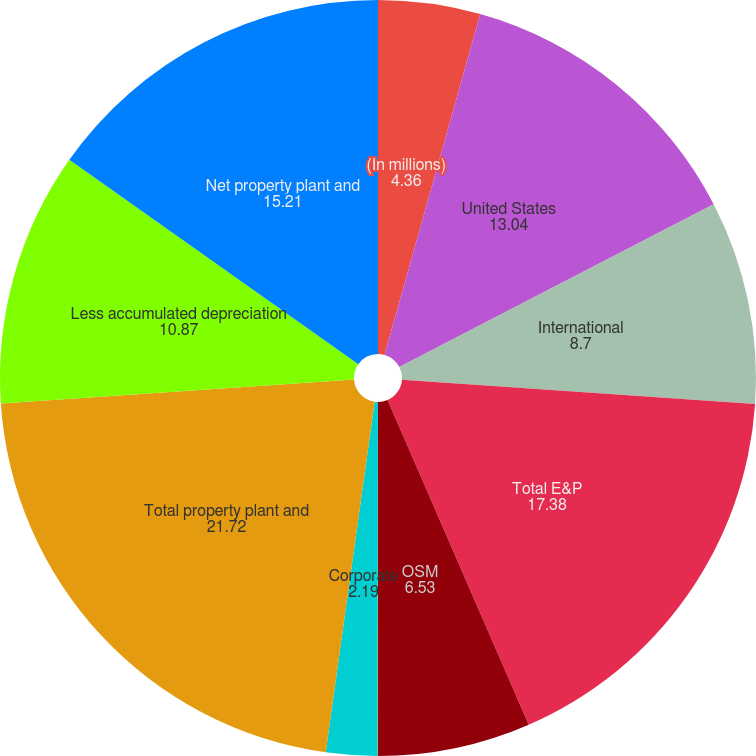Convert chart. <chart><loc_0><loc_0><loc_500><loc_500><pie_chart><fcel>(In millions)<fcel>United States<fcel>International<fcel>Total E&P<fcel>OSM<fcel>IG<fcel>Corporate<fcel>Total property plant and<fcel>Less accumulated depreciation<fcel>Net property plant and<nl><fcel>4.36%<fcel>13.04%<fcel>8.7%<fcel>17.38%<fcel>6.53%<fcel>0.02%<fcel>2.19%<fcel>21.72%<fcel>10.87%<fcel>15.21%<nl></chart> 